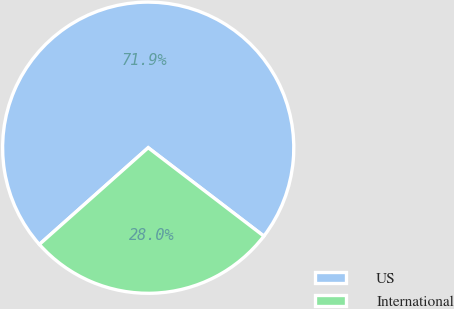Convert chart. <chart><loc_0><loc_0><loc_500><loc_500><pie_chart><fcel>US<fcel>International<nl><fcel>71.95%<fcel>28.05%<nl></chart> 